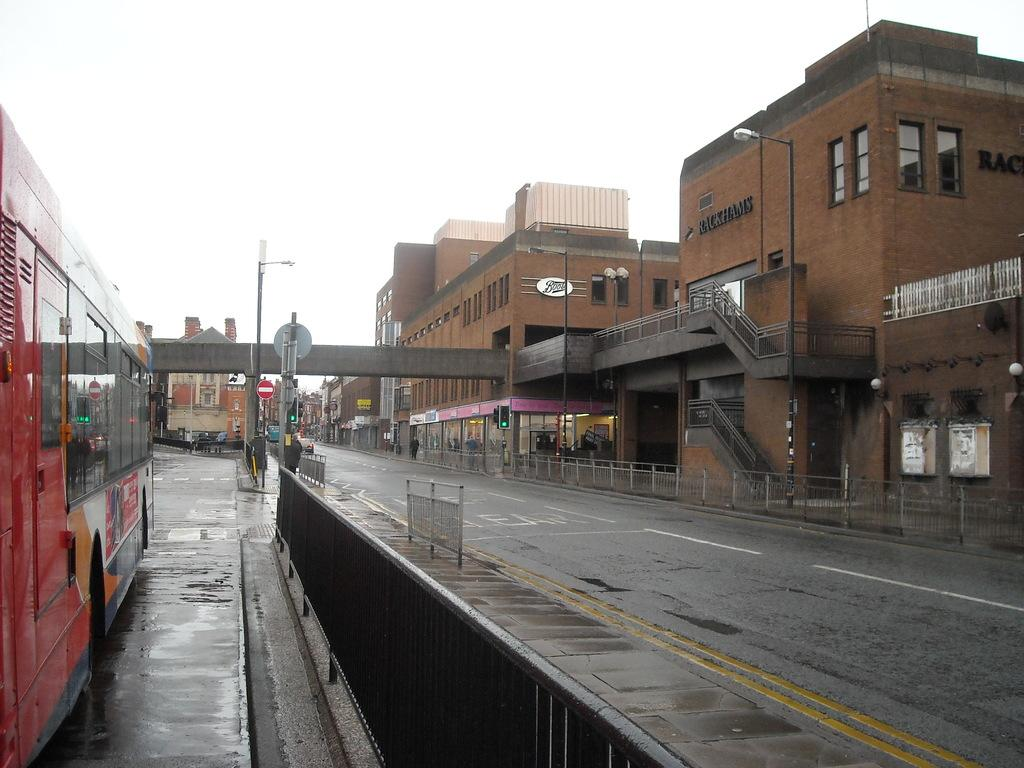<image>
Provide a brief description of the given image. A brown building has the word Rackhams on the side of it. 